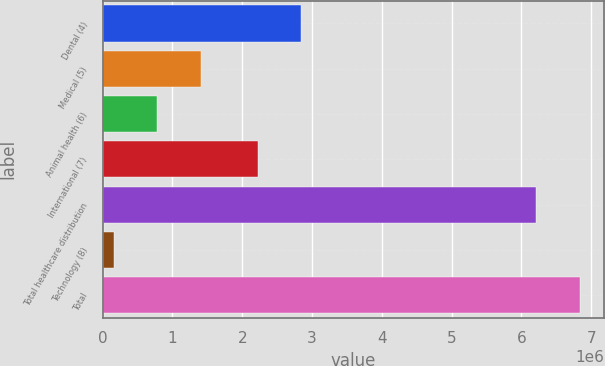<chart> <loc_0><loc_0><loc_500><loc_500><bar_chart><fcel>Dental (4)<fcel>Medical (5)<fcel>Animal health (6)<fcel>International (7)<fcel>Total healthcare distribution<fcel>Technology (8)<fcel>Total<nl><fcel>2.8428e+06<fcel>1.40671e+06<fcel>785001<fcel>2.22109e+06<fcel>6.21712e+06<fcel>163289<fcel>6.83884e+06<nl></chart> 